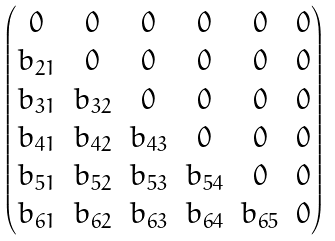<formula> <loc_0><loc_0><loc_500><loc_500>\begin{pmatrix} 0 & 0 & 0 & 0 & 0 & 0 \\ b _ { 2 1 } & 0 & 0 & 0 & 0 & 0 \\ b _ { 3 1 } & b _ { 3 2 } & 0 & 0 & 0 & 0 \\ b _ { 4 1 } & b _ { 4 2 } & b _ { 4 3 } & 0 & 0 & 0 \\ b _ { 5 1 } & b _ { 5 2 } & b _ { 5 3 } & b _ { 5 4 } & 0 & 0 \\ b _ { 6 1 } & b _ { 6 2 } & b _ { 6 3 } & b _ { 6 4 } & b _ { 6 5 } & 0 \end{pmatrix}</formula> 